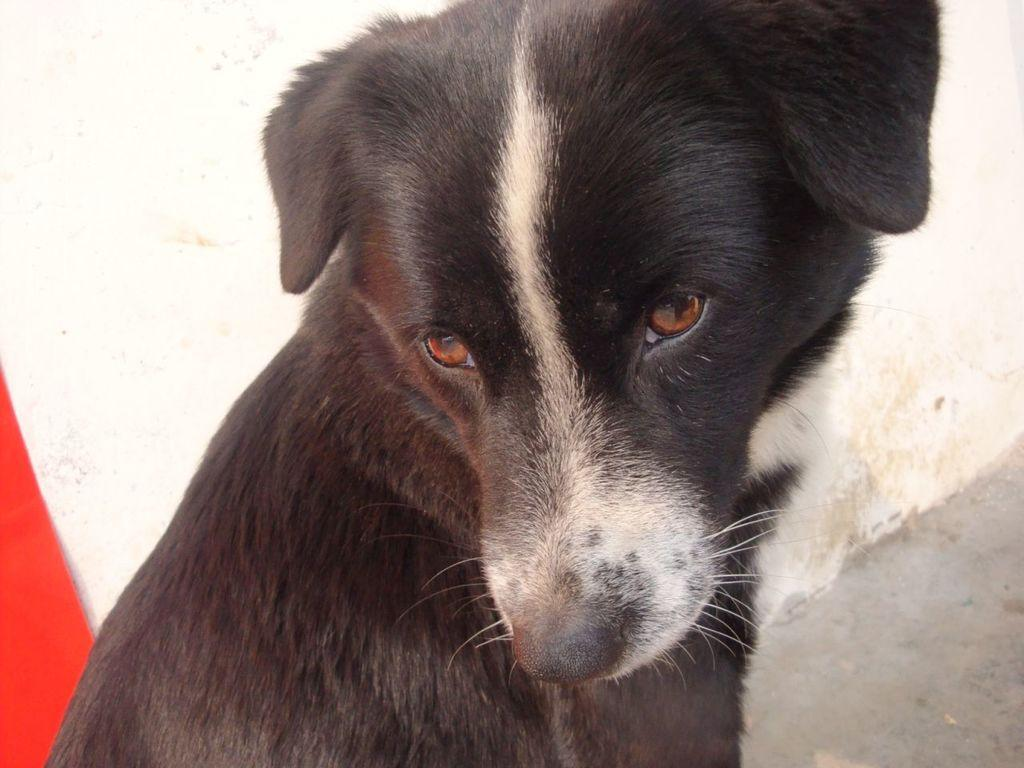What type of animal is in the picture? There is a dog in the picture. What is the dog doing in the picture? The dog is sitting. What color is the dog in the picture? The dog is black in color. What can be seen in the background of the picture? There is a white wall and a red object in the background of the picture. What type of disease is the dog suffering from in the image? There is no indication in the image that the dog is suffering from any disease. 